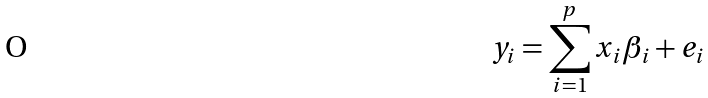<formula> <loc_0><loc_0><loc_500><loc_500>y _ { i } = \sum _ { i = 1 } ^ { p } x _ { i } \beta _ { i } + e _ { i }</formula> 